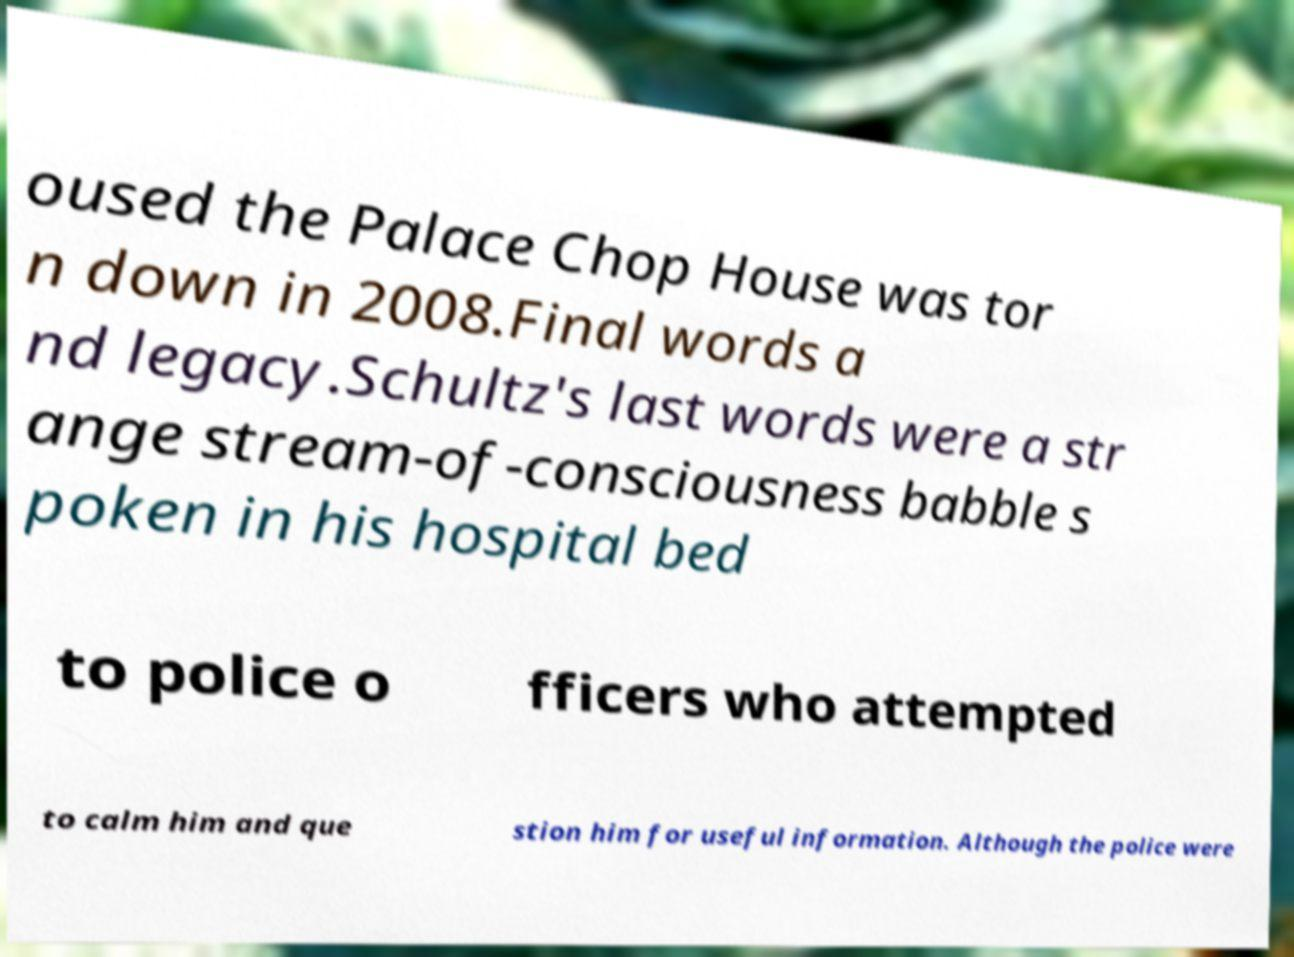What messages or text are displayed in this image? I need them in a readable, typed format. oused the Palace Chop House was tor n down in 2008.Final words a nd legacy.Schultz's last words were a str ange stream-of-consciousness babble s poken in his hospital bed to police o fficers who attempted to calm him and que stion him for useful information. Although the police were 